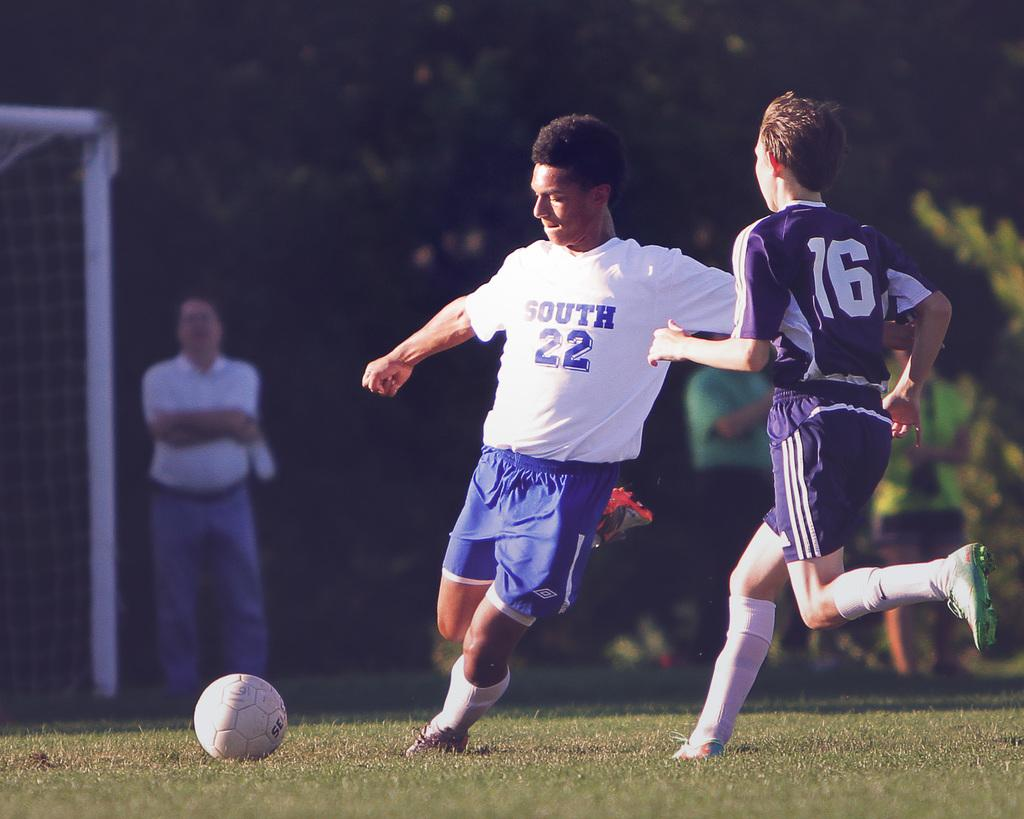<image>
Relay a brief, clear account of the picture shown. A soccer player in a blue and white uniform with the number 22 on his shirt is kicking the ball. 